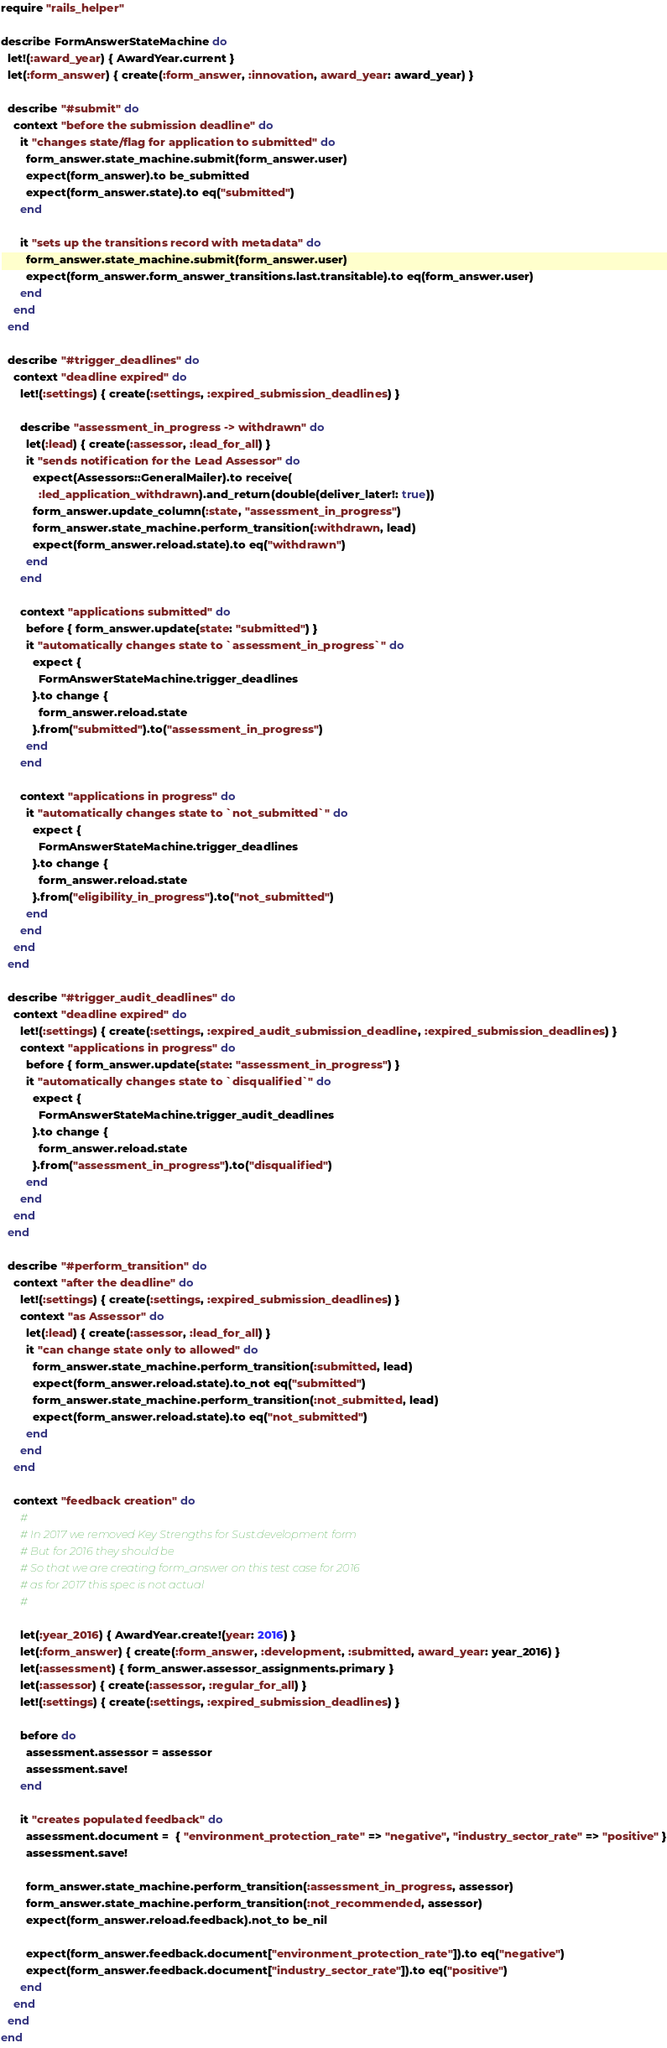Convert code to text. <code><loc_0><loc_0><loc_500><loc_500><_Ruby_>require "rails_helper"

describe FormAnswerStateMachine do
  let!(:award_year) { AwardYear.current }
  let(:form_answer) { create(:form_answer, :innovation, award_year: award_year) }

  describe "#submit" do
    context "before the submission deadline" do
      it "changes state/flag for application to submitted" do
        form_answer.state_machine.submit(form_answer.user)
        expect(form_answer).to be_submitted
        expect(form_answer.state).to eq("submitted")
      end

      it "sets up the transitions record with metadata" do
        form_answer.state_machine.submit(form_answer.user)
        expect(form_answer.form_answer_transitions.last.transitable).to eq(form_answer.user)
      end
    end
  end

  describe "#trigger_deadlines" do
    context "deadline expired" do
      let!(:settings) { create(:settings, :expired_submission_deadlines) }

      describe "assessment_in_progress -> withdrawn" do
        let(:lead) { create(:assessor, :lead_for_all) }
        it "sends notification for the Lead Assessor" do
          expect(Assessors::GeneralMailer).to receive(
            :led_application_withdrawn).and_return(double(deliver_later!: true))
          form_answer.update_column(:state, "assessment_in_progress")
          form_answer.state_machine.perform_transition(:withdrawn, lead)
          expect(form_answer.reload.state).to eq("withdrawn")
        end
      end

      context "applications submitted" do
        before { form_answer.update(state: "submitted") }
        it "automatically changes state to `assessment_in_progress`" do
          expect {
            FormAnswerStateMachine.trigger_deadlines
          }.to change {
            form_answer.reload.state
          }.from("submitted").to("assessment_in_progress")
        end
      end

      context "applications in progress" do
        it "automatically changes state to `not_submitted`" do
          expect {
            FormAnswerStateMachine.trigger_deadlines
          }.to change {
            form_answer.reload.state
          }.from("eligibility_in_progress").to("not_submitted")
        end
      end
    end
  end

  describe "#trigger_audit_deadlines" do
    context "deadline expired" do
      let!(:settings) { create(:settings, :expired_audit_submission_deadline, :expired_submission_deadlines) }
      context "applications in progress" do
        before { form_answer.update(state: "assessment_in_progress") }
        it "automatically changes state to `disqualified`" do
          expect {
            FormAnswerStateMachine.trigger_audit_deadlines
          }.to change {
            form_answer.reload.state
          }.from("assessment_in_progress").to("disqualified")
        end
      end
    end
  end

  describe "#perform_transition" do
    context "after the deadline" do
      let!(:settings) { create(:settings, :expired_submission_deadlines) }
      context "as Assessor" do
        let(:lead) { create(:assessor, :lead_for_all) }
        it "can change state only to allowed" do
          form_answer.state_machine.perform_transition(:submitted, lead)
          expect(form_answer.reload.state).to_not eq("submitted")
          form_answer.state_machine.perform_transition(:not_submitted, lead)
          expect(form_answer.reload.state).to eq("not_submitted")
        end
      end
    end

    context "feedback creation" do
      #
      # In 2017 we removed Key Strengths for Sust.development form
      # But for 2016 they should be
      # So that we are creating form_answer on this test case for 2016
      # as for 2017 this spec is not actual
      #

      let(:year_2016) { AwardYear.create!(year: 2016) }
      let(:form_answer) { create(:form_answer, :development, :submitted, award_year: year_2016) }
      let(:assessment) { form_answer.assessor_assignments.primary }
      let(:assessor) { create(:assessor, :regular_for_all) }
      let!(:settings) { create(:settings, :expired_submission_deadlines) }

      before do
        assessment.assessor = assessor
        assessment.save!
      end

      it "creates populated feedback" do
        assessment.document =  { "environment_protection_rate" => "negative", "industry_sector_rate" => "positive" }
        assessment.save!

        form_answer.state_machine.perform_transition(:assessment_in_progress, assessor)
        form_answer.state_machine.perform_transition(:not_recommended, assessor)
        expect(form_answer.reload.feedback).not_to be_nil

        expect(form_answer.feedback.document["environment_protection_rate"]).to eq("negative")
        expect(form_answer.feedback.document["industry_sector_rate"]).to eq("positive")
      end
    end
  end
end
</code> 